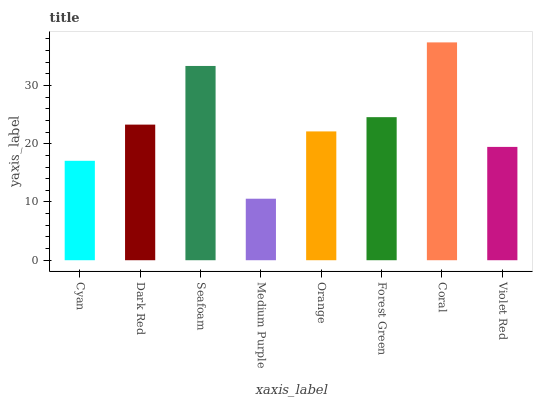Is Medium Purple the minimum?
Answer yes or no. Yes. Is Coral the maximum?
Answer yes or no. Yes. Is Dark Red the minimum?
Answer yes or no. No. Is Dark Red the maximum?
Answer yes or no. No. Is Dark Red greater than Cyan?
Answer yes or no. Yes. Is Cyan less than Dark Red?
Answer yes or no. Yes. Is Cyan greater than Dark Red?
Answer yes or no. No. Is Dark Red less than Cyan?
Answer yes or no. No. Is Dark Red the high median?
Answer yes or no. Yes. Is Orange the low median?
Answer yes or no. Yes. Is Coral the high median?
Answer yes or no. No. Is Forest Green the low median?
Answer yes or no. No. 